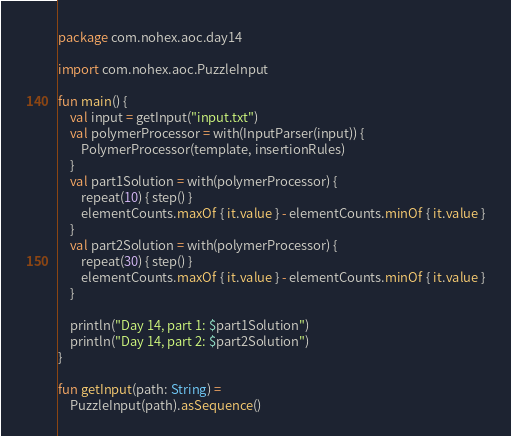<code> <loc_0><loc_0><loc_500><loc_500><_Kotlin_>package com.nohex.aoc.day14

import com.nohex.aoc.PuzzleInput

fun main() {
    val input = getInput("input.txt")
    val polymerProcessor = with(InputParser(input)) {
        PolymerProcessor(template, insertionRules)
    }
    val part1Solution = with(polymerProcessor) {
        repeat(10) { step() }
        elementCounts.maxOf { it.value } - elementCounts.minOf { it.value }
    }
    val part2Solution = with(polymerProcessor) {
        repeat(30) { step() }
        elementCounts.maxOf { it.value } - elementCounts.minOf { it.value }
    }

    println("Day 14, part 1: $part1Solution")
    println("Day 14, part 2: $part2Solution")
}

fun getInput(path: String) =
    PuzzleInput(path).asSequence()
</code> 